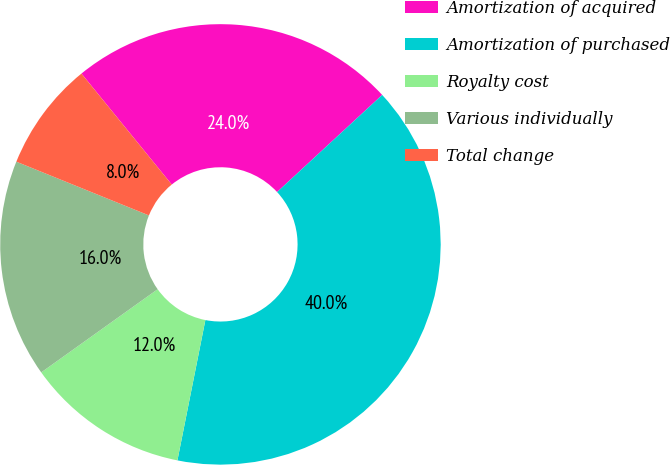<chart> <loc_0><loc_0><loc_500><loc_500><pie_chart><fcel>Amortization of acquired<fcel>Amortization of purchased<fcel>Royalty cost<fcel>Various individually<fcel>Total change<nl><fcel>24.0%<fcel>40.0%<fcel>12.0%<fcel>16.0%<fcel>8.0%<nl></chart> 